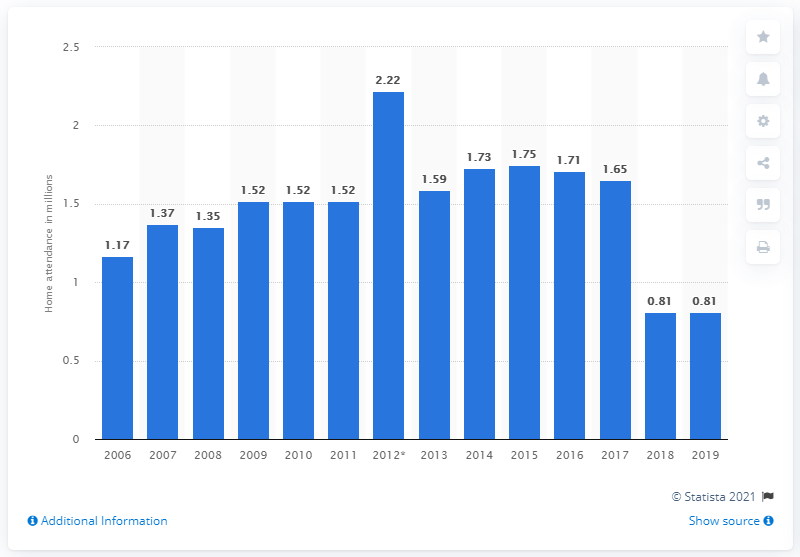List a handful of essential elements in this visual. In the 2019 regular season, the Miami Marlins' home attendance was 0.81. 